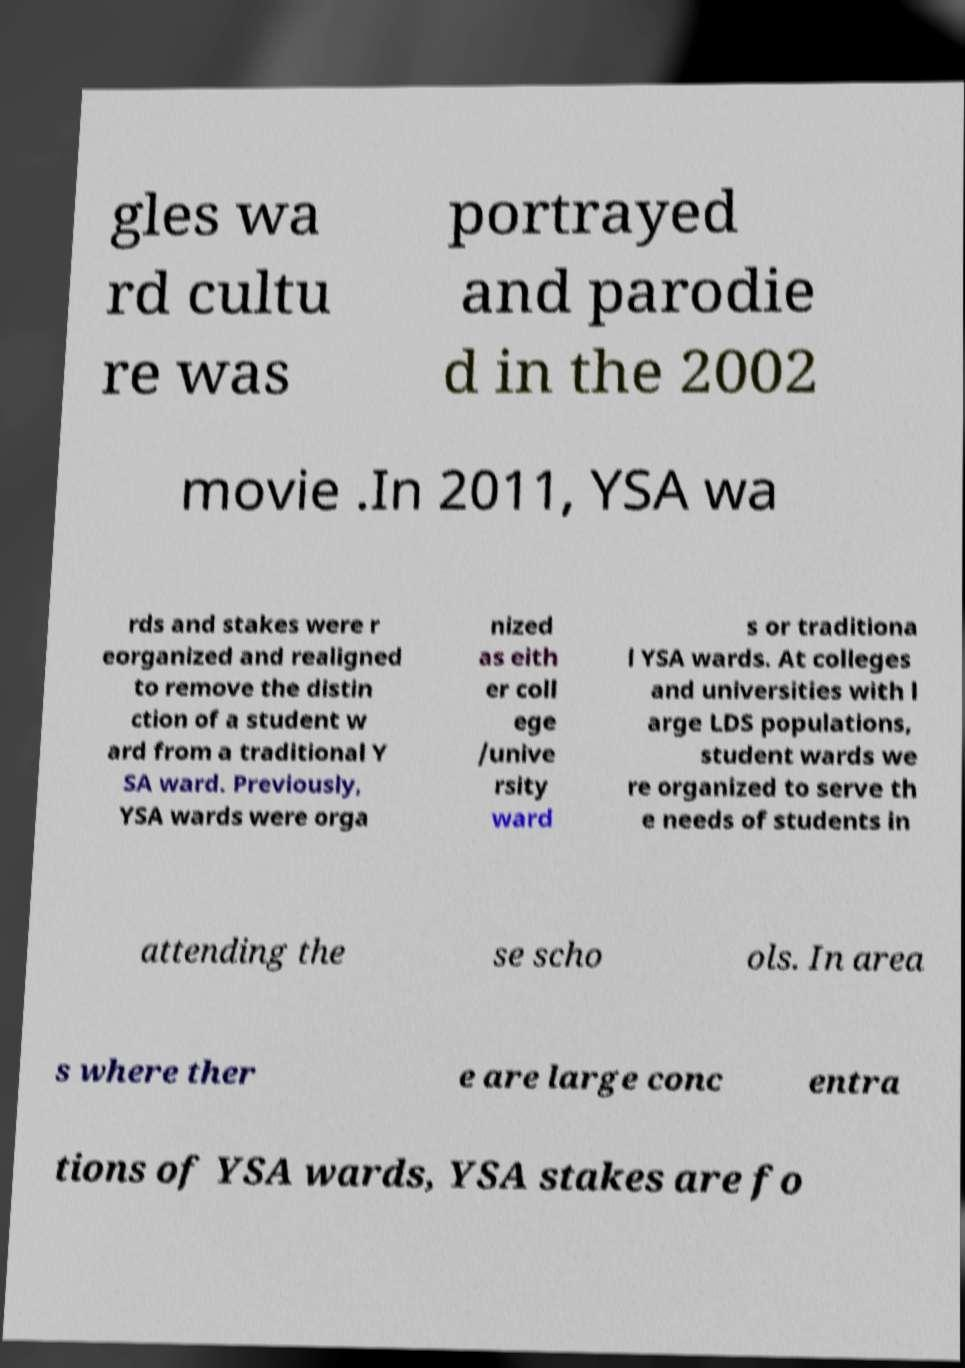What messages or text are displayed in this image? I need them in a readable, typed format. gles wa rd cultu re was portrayed and parodie d in the 2002 movie .In 2011, YSA wa rds and stakes were r eorganized and realigned to remove the distin ction of a student w ard from a traditional Y SA ward. Previously, YSA wards were orga nized as eith er coll ege /unive rsity ward s or traditiona l YSA wards. At colleges and universities with l arge LDS populations, student wards we re organized to serve th e needs of students in attending the se scho ols. In area s where ther e are large conc entra tions of YSA wards, YSA stakes are fo 